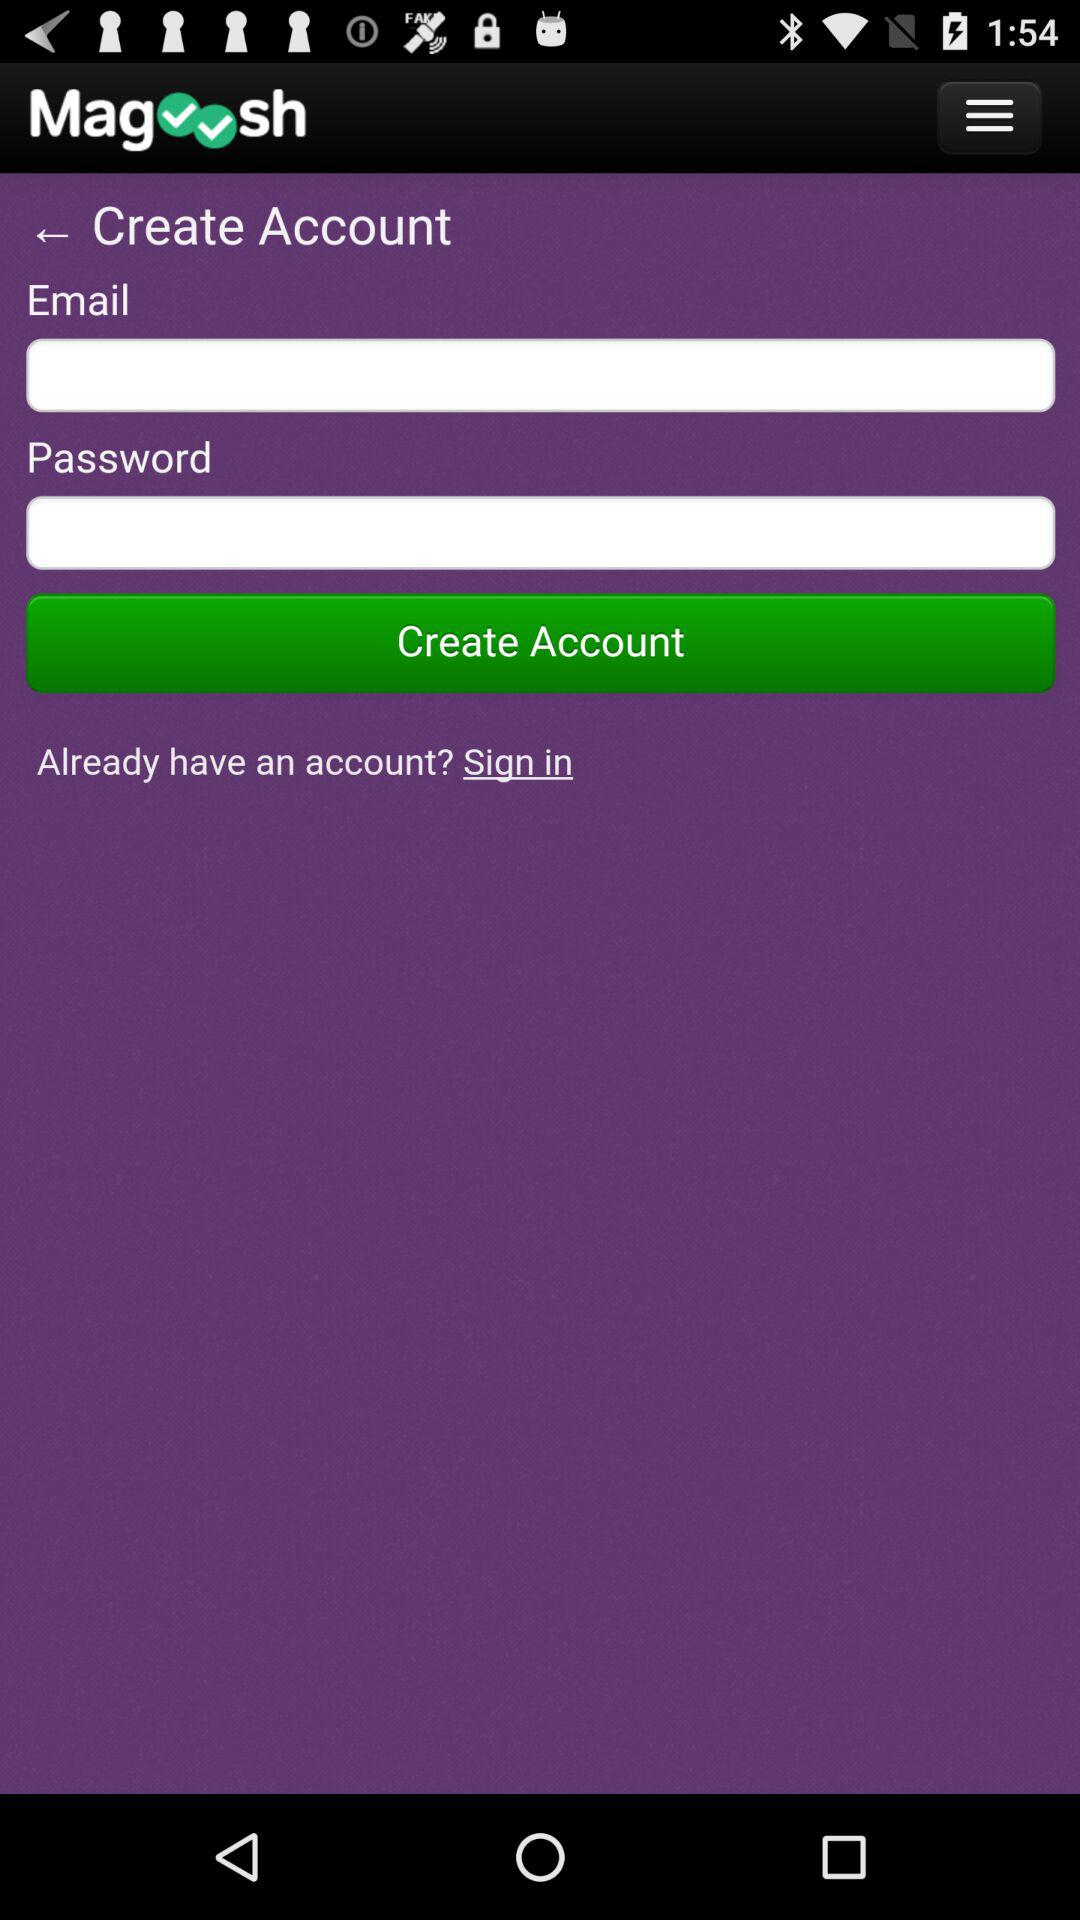What is the name of the application? The application name is "Magoosh". 